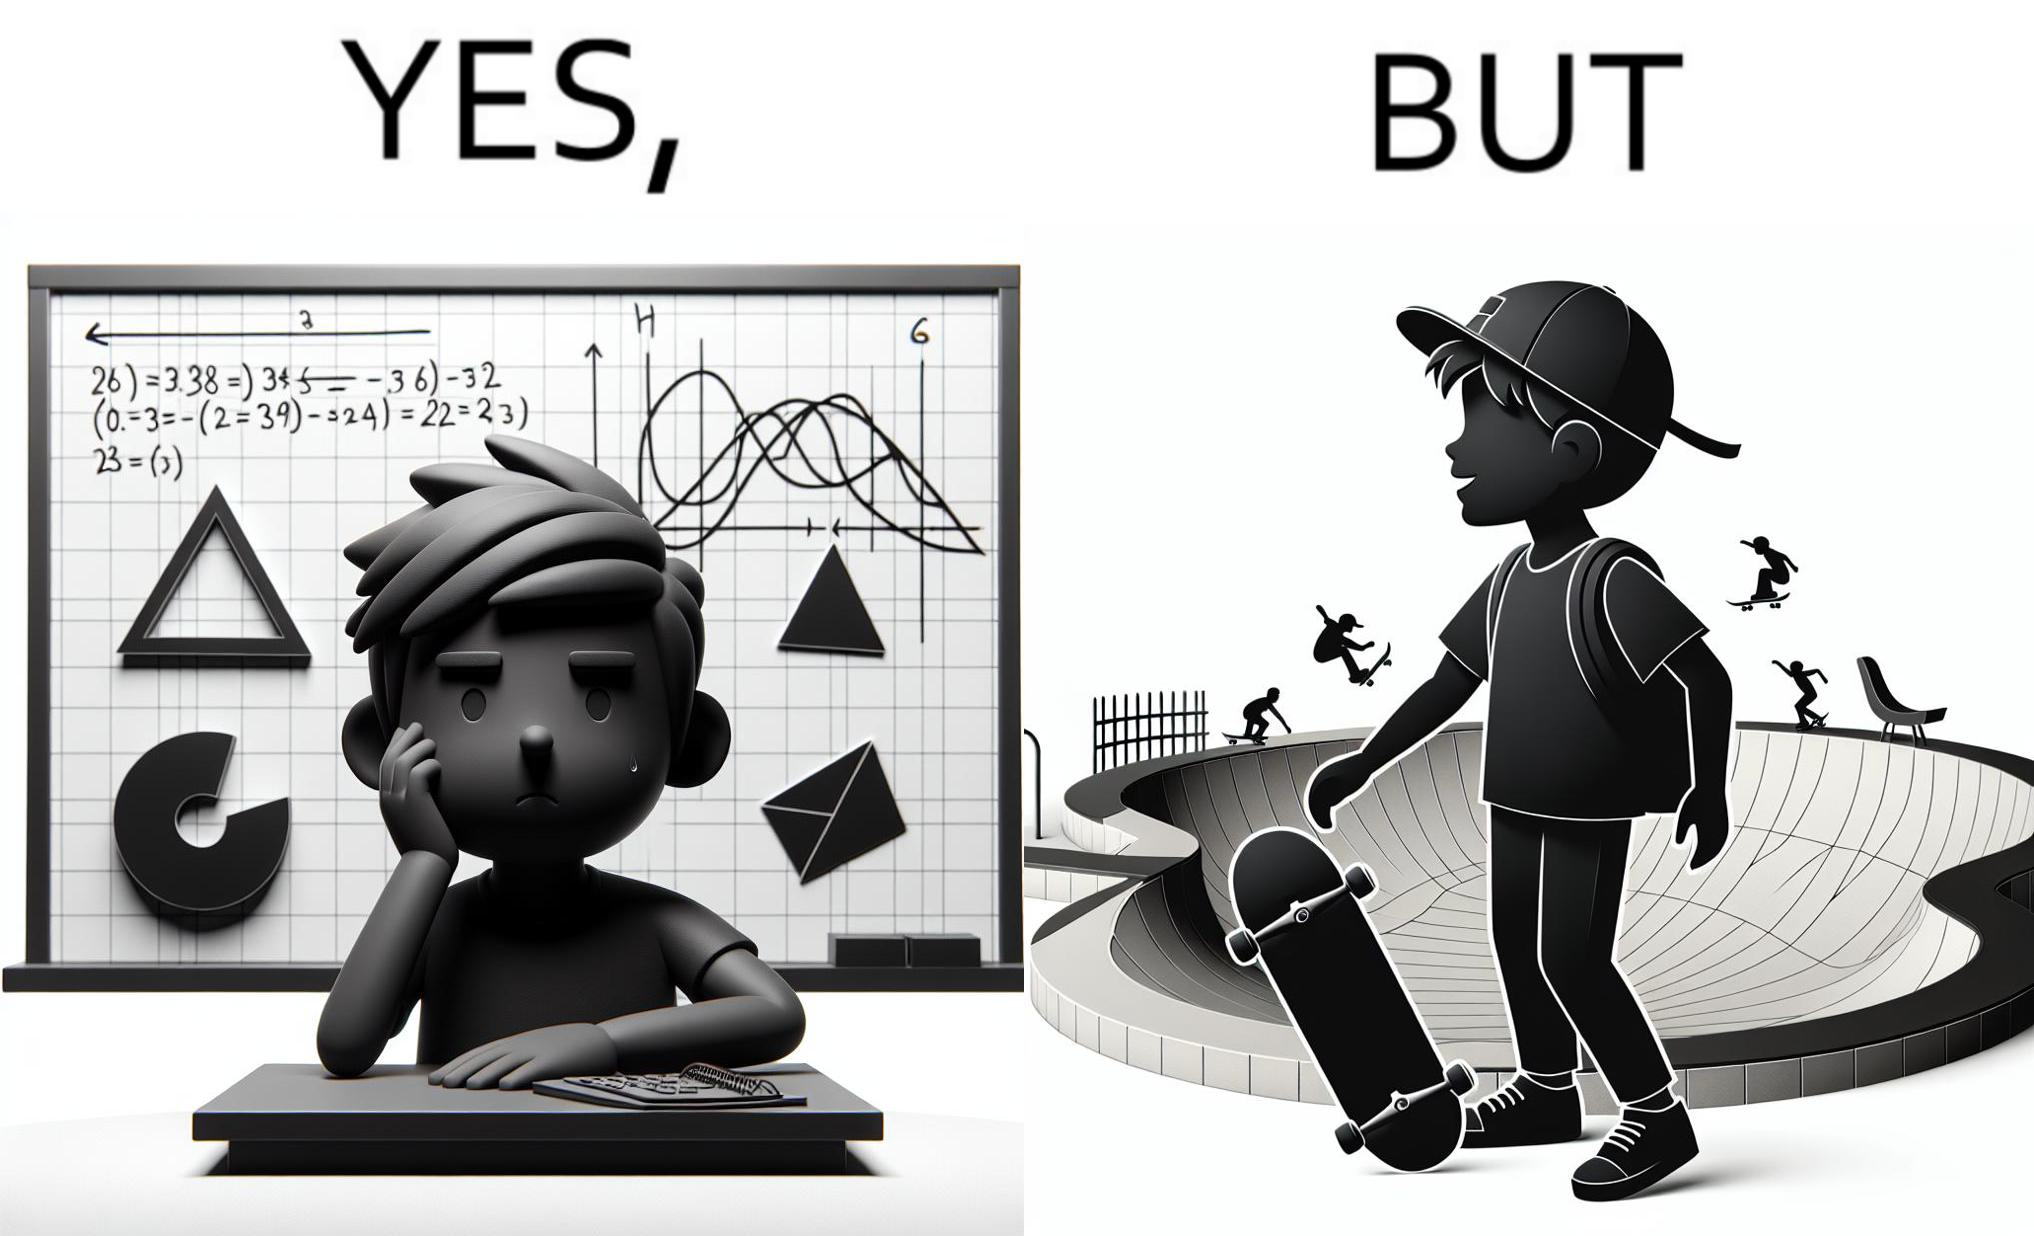What do you see in each half of this image? In the left part of the image: The image shows a boy annoyed with studying maths. Behind him is a board with lots of shapes like  semi-circle and trapezoid drawn along with mathematical formulas like areas of circle. There is a graph of sinusodial curve also drawn on the board. In the right part of the image: The image shows a boy wearing a cap with a skateboard in his hands. He is happy. In his background there is a skateboard park. In the background there is a person skateboarding on a semi cirular bowl. We also see bowls of other shapes like trapezoid and sine wave. 